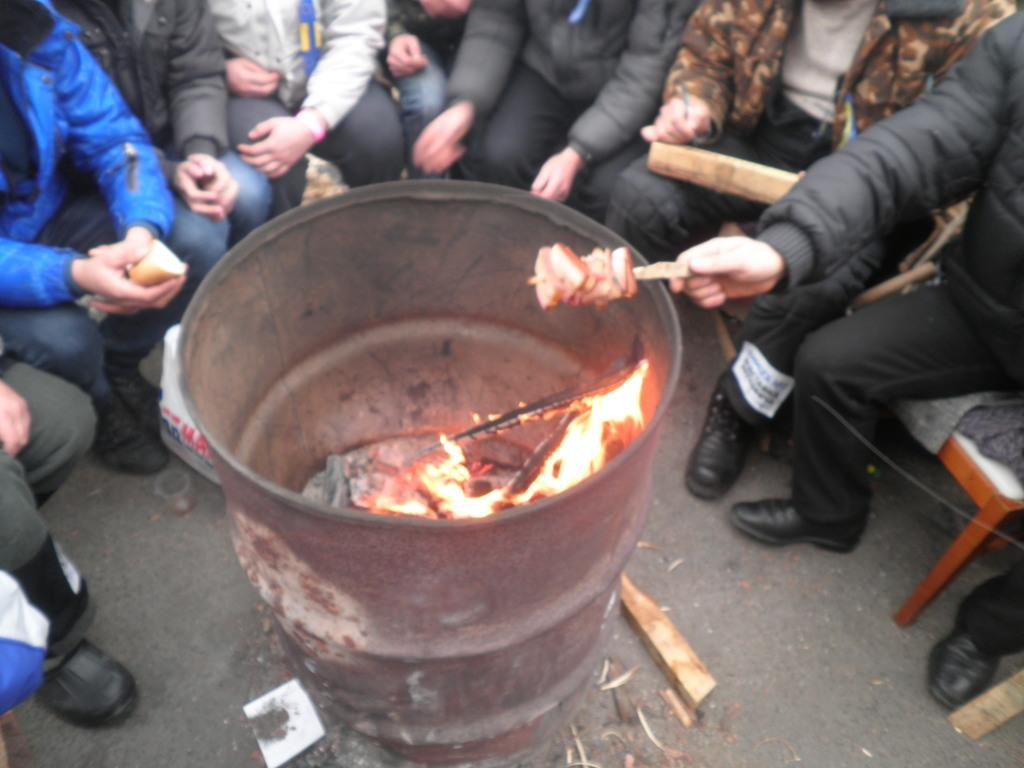What is the main object in the foreground of the image? There is a drum in the foreground of the image. What is happening near the drum? There is fire in the foreground of the image, and people are sitting on chairs around the drum and fire. What is the man holding in the image? A man is holding food with a stick. What type of language is being spoken by the bear in the image? There is no bear present in the image, so it is not possible to determine what language might be spoken. 